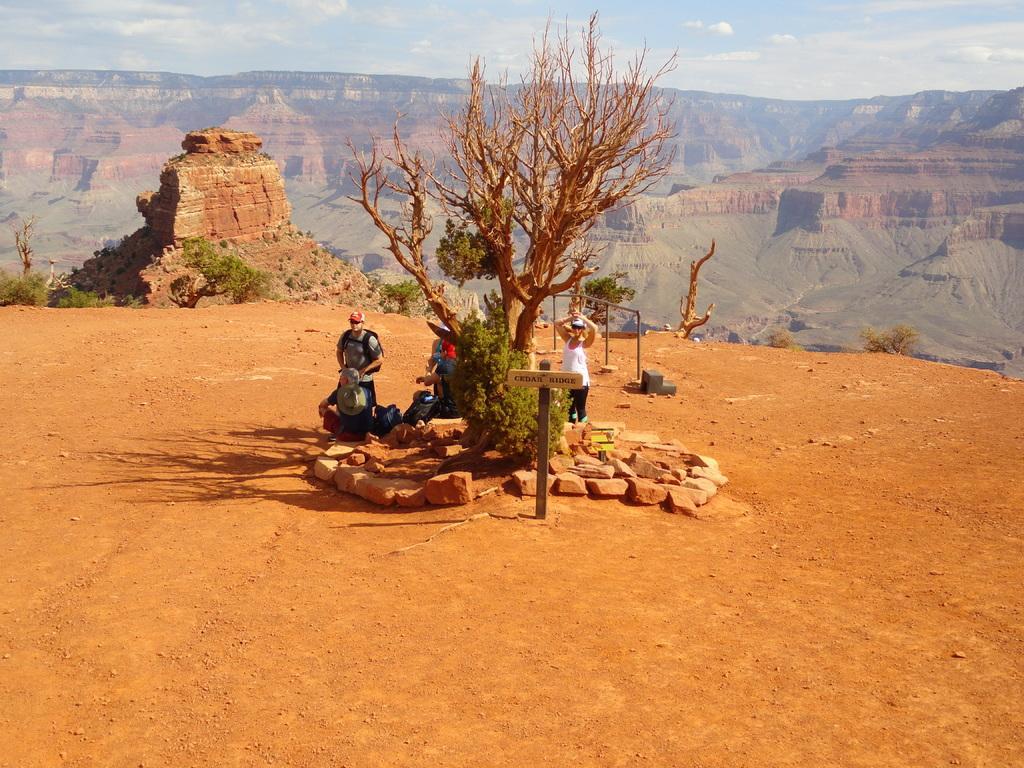Describe this image in one or two sentences. This picture is clicked outside. In the center we can see the rocks, plants, group of people and the dry stems. In the background we can see the sky, mountains and the green leaves and many other objects. 